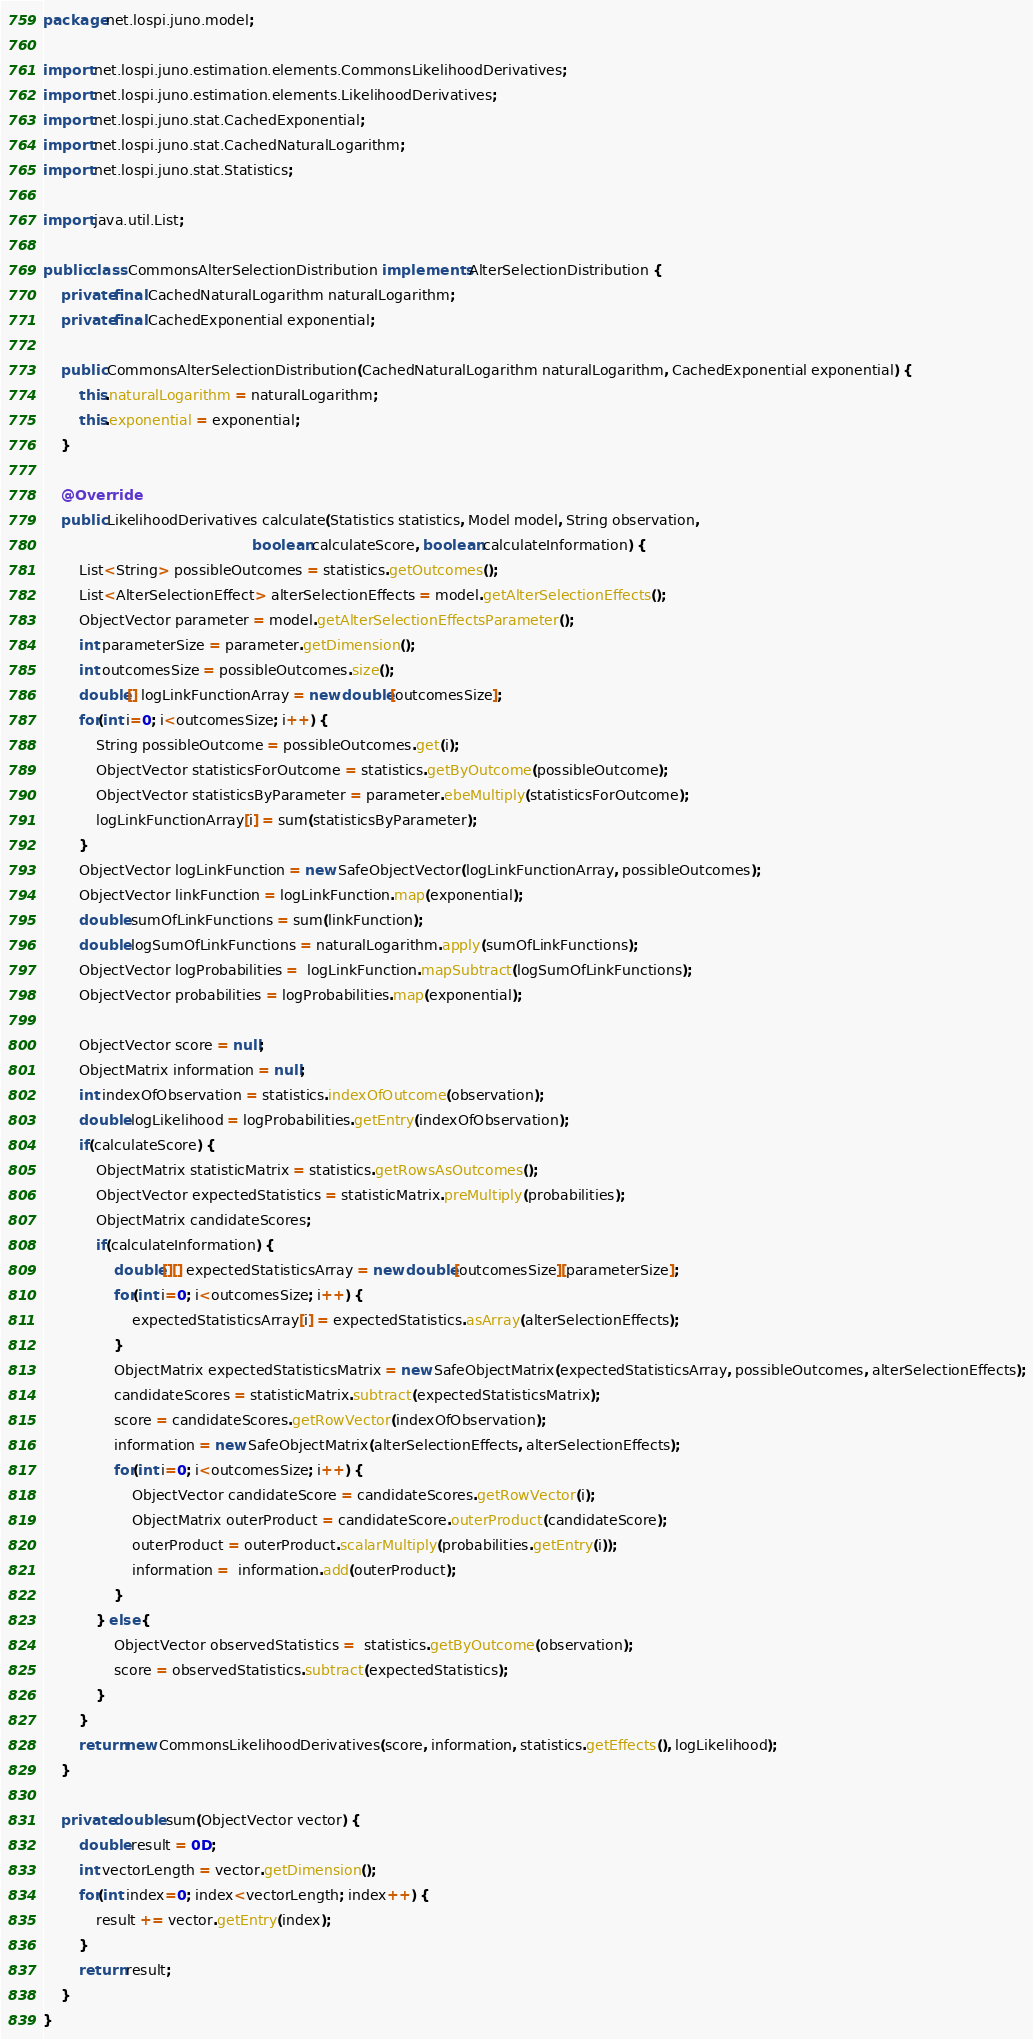<code> <loc_0><loc_0><loc_500><loc_500><_Java_>package net.lospi.juno.model;

import net.lospi.juno.estimation.elements.CommonsLikelihoodDerivatives;
import net.lospi.juno.estimation.elements.LikelihoodDerivatives;
import net.lospi.juno.stat.CachedExponential;
import net.lospi.juno.stat.CachedNaturalLogarithm;
import net.lospi.juno.stat.Statistics;

import java.util.List;

public class CommonsAlterSelectionDistribution implements AlterSelectionDistribution {
    private final CachedNaturalLogarithm naturalLogarithm;
    private final CachedExponential exponential;

    public CommonsAlterSelectionDistribution(CachedNaturalLogarithm naturalLogarithm, CachedExponential exponential) {
        this.naturalLogarithm = naturalLogarithm;
        this.exponential = exponential;
    }

    @Override
    public LikelihoodDerivatives calculate(Statistics statistics, Model model, String observation,
                                               boolean calculateScore, boolean calculateInformation) {
        List<String> possibleOutcomes = statistics.getOutcomes();
        List<AlterSelectionEffect> alterSelectionEffects = model.getAlterSelectionEffects();
        ObjectVector parameter = model.getAlterSelectionEffectsParameter();
        int parameterSize = parameter.getDimension();
        int outcomesSize = possibleOutcomes.size();
        double[] logLinkFunctionArray = new double[outcomesSize];
        for(int i=0; i<outcomesSize; i++) {
            String possibleOutcome = possibleOutcomes.get(i);
            ObjectVector statisticsForOutcome = statistics.getByOutcome(possibleOutcome);
            ObjectVector statisticsByParameter = parameter.ebeMultiply(statisticsForOutcome);
            logLinkFunctionArray[i] = sum(statisticsByParameter);
        }
        ObjectVector logLinkFunction = new SafeObjectVector(logLinkFunctionArray, possibleOutcomes);
        ObjectVector linkFunction = logLinkFunction.map(exponential);
        double sumOfLinkFunctions = sum(linkFunction);
        double logSumOfLinkFunctions = naturalLogarithm.apply(sumOfLinkFunctions);
        ObjectVector logProbabilities =  logLinkFunction.mapSubtract(logSumOfLinkFunctions);
        ObjectVector probabilities = logProbabilities.map(exponential);

        ObjectVector score = null;
        ObjectMatrix information = null;
        int indexOfObservation = statistics.indexOfOutcome(observation);
        double logLikelihood = logProbabilities.getEntry(indexOfObservation);
        if(calculateScore) {
            ObjectMatrix statisticMatrix = statistics.getRowsAsOutcomes();
            ObjectVector expectedStatistics = statisticMatrix.preMultiply(probabilities);
            ObjectMatrix candidateScores;
            if(calculateInformation) {
                double[][] expectedStatisticsArray = new double[outcomesSize][parameterSize];
                for(int i=0; i<outcomesSize; i++) {
                    expectedStatisticsArray[i] = expectedStatistics.asArray(alterSelectionEffects);
                }
                ObjectMatrix expectedStatisticsMatrix = new SafeObjectMatrix(expectedStatisticsArray, possibleOutcomes, alterSelectionEffects);
                candidateScores = statisticMatrix.subtract(expectedStatisticsMatrix);
                score = candidateScores.getRowVector(indexOfObservation);
                information = new SafeObjectMatrix(alterSelectionEffects, alterSelectionEffects);
                for(int i=0; i<outcomesSize; i++) {
                    ObjectVector candidateScore = candidateScores.getRowVector(i);
                    ObjectMatrix outerProduct = candidateScore.outerProduct(candidateScore);
                    outerProduct = outerProduct.scalarMultiply(probabilities.getEntry(i));
                    information =  information.add(outerProduct);
                }
            } else {
                ObjectVector observedStatistics =  statistics.getByOutcome(observation);
                score = observedStatistics.subtract(expectedStatistics);
            }
        }
        return new CommonsLikelihoodDerivatives(score, information, statistics.getEffects(), logLikelihood);
    }

    private double sum(ObjectVector vector) {
        double result = 0D;
        int vectorLength = vector.getDimension();
        for(int index=0; index<vectorLength; index++) {
            result += vector.getEntry(index);
        }
        return result;
    }
}
</code> 